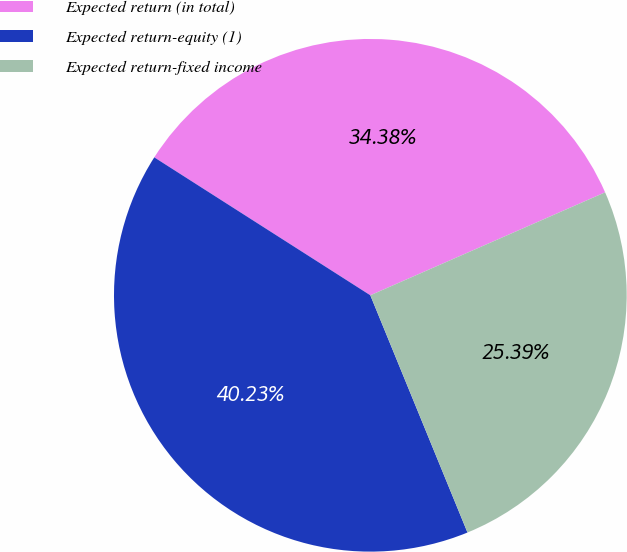<chart> <loc_0><loc_0><loc_500><loc_500><pie_chart><fcel>Expected return (in total)<fcel>Expected return-equity (1)<fcel>Expected return-fixed income<nl><fcel>34.38%<fcel>40.23%<fcel>25.39%<nl></chart> 